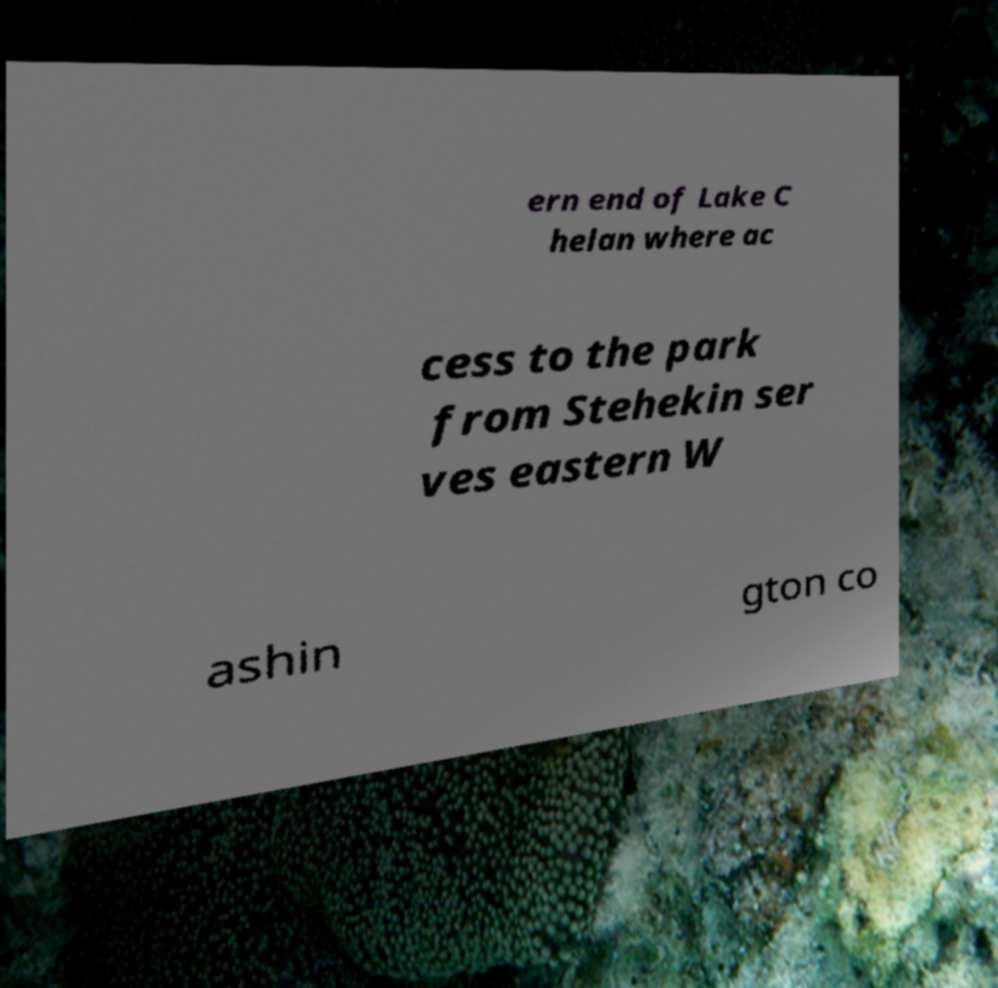Please identify and transcribe the text found in this image. ern end of Lake C helan where ac cess to the park from Stehekin ser ves eastern W ashin gton co 